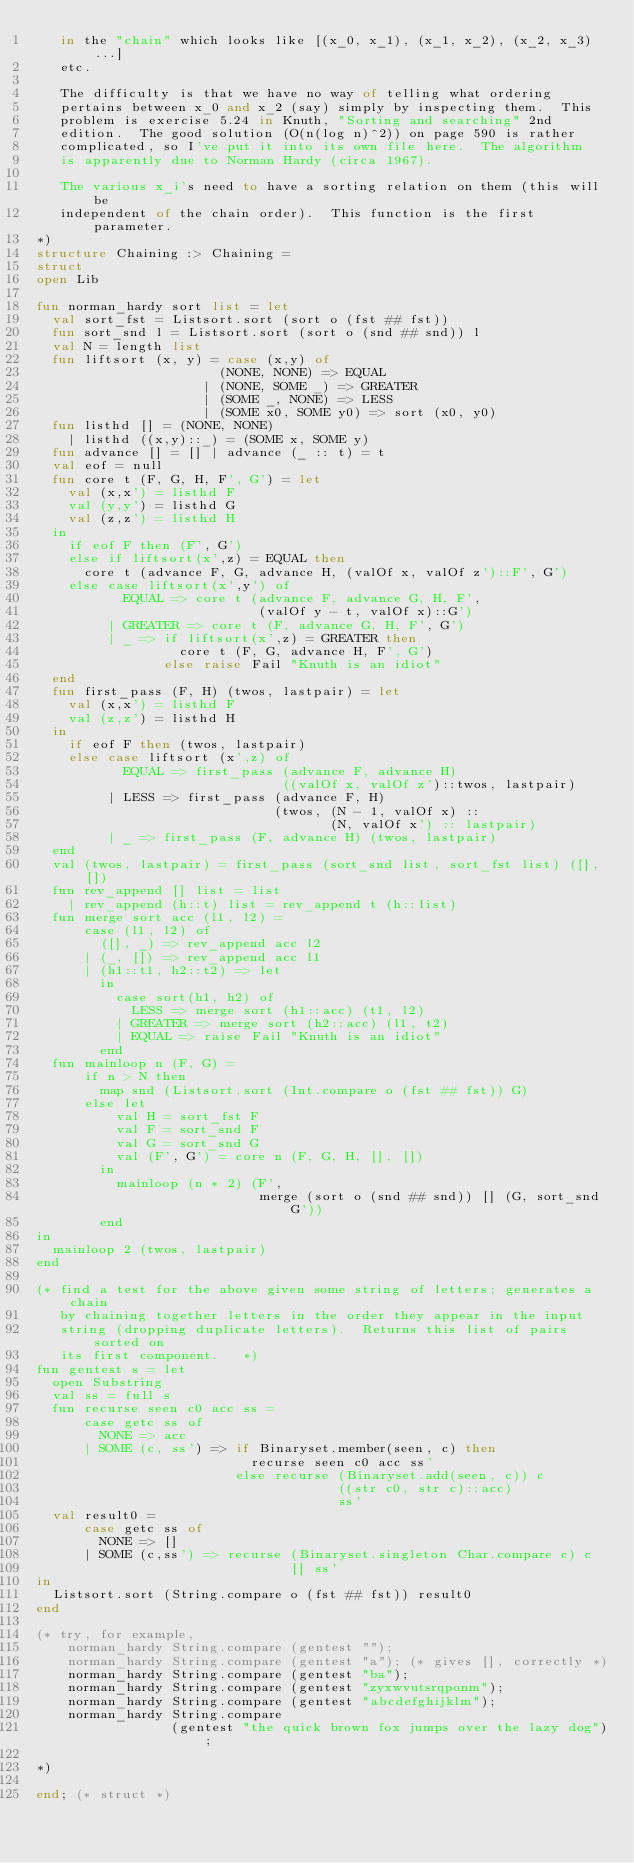<code> <loc_0><loc_0><loc_500><loc_500><_SML_>   in the "chain" which looks like [(x_0, x_1), (x_1, x_2), (x_2, x_3) ...]
   etc.

   The difficulty is that we have no way of telling what ordering
   pertains between x_0 and x_2 (say) simply by inspecting them.  This
   problem is exercise 5.24 in Knuth, "Sorting and searching" 2nd
   edition.  The good solution (O(n(log n)^2)) on page 590 is rather
   complicated, so I've put it into its own file here.  The algorithm
   is apparently due to Norman Hardy (circa 1967).

   The various x_i's need to have a sorting relation on them (this will be
   independent of the chain order).  This function is the first parameter.
*)
structure Chaining :> Chaining =
struct
open Lib

fun norman_hardy sort list = let
  val sort_fst = Listsort.sort (sort o (fst ## fst))
  fun sort_snd l = Listsort.sort (sort o (snd ## snd)) l
  val N = length list
  fun liftsort (x, y) = case (x,y) of
                       (NONE, NONE) => EQUAL
                     | (NONE, SOME _) => GREATER
                     | (SOME _, NONE) => LESS
                     | (SOME x0, SOME y0) => sort (x0, y0)
  fun listhd [] = (NONE, NONE)
    | listhd ((x,y)::_) = (SOME x, SOME y)
  fun advance [] = [] | advance (_ :: t) = t
  val eof = null
  fun core t (F, G, H, F', G') = let
    val (x,x') = listhd F
    val (y,y') = listhd G
    val (z,z') = listhd H
  in
    if eof F then (F', G')
    else if liftsort(x',z) = EQUAL then
      core t (advance F, G, advance H, (valOf x, valOf z')::F', G')
    else case liftsort(x',y') of
           EQUAL => core t (advance F, advance G, H, F',
                            (valOf y - t, valOf x)::G')
         | GREATER => core t (F, advance G, H, F', G')
         | _ => if liftsort(x',z) = GREATER then
                  core t (F, G, advance H, F', G')
                else raise Fail "Knuth is an idiot"
  end
  fun first_pass (F, H) (twos, lastpair) = let
    val (x,x') = listhd F
    val (z,z') = listhd H
  in
    if eof F then (twos, lastpair)
    else case liftsort (x',z) of
           EQUAL => first_pass (advance F, advance H)
                               ((valOf x, valOf z')::twos, lastpair)
         | LESS => first_pass (advance F, H)
                              (twos, (N - 1, valOf x) ::
                                     (N, valOf x') :: lastpair)
         | _ => first_pass (F, advance H) (twos, lastpair)
  end
  val (twos, lastpair) = first_pass (sort_snd list, sort_fst list) ([], [])
  fun rev_append [] list = list
    | rev_append (h::t) list = rev_append t (h::list)
  fun merge sort acc (l1, l2) =
      case (l1, l2) of
        ([], _) => rev_append acc l2
      | (_, []) => rev_append acc l1
      | (h1::t1, h2::t2) => let
        in
          case sort(h1, h2) of
            LESS => merge sort (h1::acc) (t1, l2)
          | GREATER => merge sort (h2::acc) (l1, t2)
          | EQUAL => raise Fail "Knuth is an idiot"
        end
  fun mainloop n (F, G) =
      if n > N then
        map snd (Listsort.sort (Int.compare o (fst ## fst)) G)
      else let
          val H = sort_fst F
          val F = sort_snd F
          val G = sort_snd G
          val (F', G') = core n (F, G, H, [], [])
        in
          mainloop (n * 2) (F',
                            merge (sort o (snd ## snd)) [] (G, sort_snd G'))
        end
in
  mainloop 2 (twos, lastpair)
end

(* find a test for the above given some string of letters; generates a chain
   by chaining together letters in the order they appear in the input
   string (dropping duplicate letters).  Returns this list of pairs sorted on
   its first component.   *)
fun gentest s = let
  open Substring
  val ss = full s
  fun recurse seen c0 acc ss =
      case getc ss of
        NONE => acc
      | SOME (c, ss') => if Binaryset.member(seen, c) then
                           recurse seen c0 acc ss'
                         else recurse (Binaryset.add(seen, c)) c
                                      ((str c0, str c)::acc)
                                      ss'
  val result0 =
      case getc ss of
        NONE => []
      | SOME (c,ss') => recurse (Binaryset.singleton Char.compare c) c
                                [] ss'
in
  Listsort.sort (String.compare o (fst ## fst)) result0
end

(* try, for example,
    norman_hardy String.compare (gentest "");
    norman_hardy String.compare (gentest "a"); (* gives [], correctly *)
    norman_hardy String.compare (gentest "ba");
    norman_hardy String.compare (gentest "zyxwvutsrqponm");
    norman_hardy String.compare (gentest "abcdefghijklm");
    norman_hardy String.compare
                 (gentest "the quick brown fox jumps over the lazy dog");

*)

end; (* struct *)
</code> 